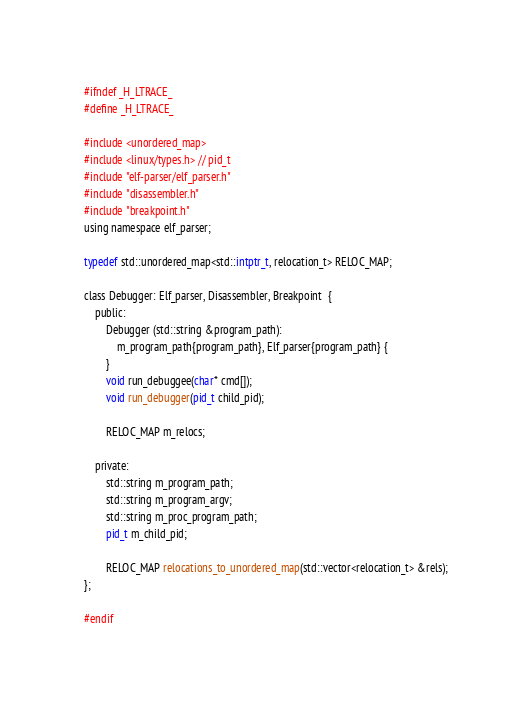Convert code to text. <code><loc_0><loc_0><loc_500><loc_500><_C_>#ifndef _H_LTRACE_
#define _H_LTRACE_

#include <unordered_map>
#include <linux/types.h> // pid_t
#include "elf-parser/elf_parser.h"
#include "disassembler.h"
#include "breakpoint.h"
using namespace elf_parser;

typedef std::unordered_map<std::intptr_t, relocation_t> RELOC_MAP;

class Debugger: Elf_parser, Disassembler, Breakpoint  {
    public:
        Debugger (std::string &program_path): 
            m_program_path{program_path}, Elf_parser{program_path} {   
        }
        void run_debuggee(char* cmd[]);   
        void run_debugger(pid_t child_pid);

        RELOC_MAP m_relocs;
        
    private:
        std::string m_program_path;
        std::string m_program_argv;
        std::string m_proc_program_path; 
        pid_t m_child_pid;
        
        RELOC_MAP relocations_to_unordered_map(std::vector<relocation_t> &rels);
};

#endif</code> 